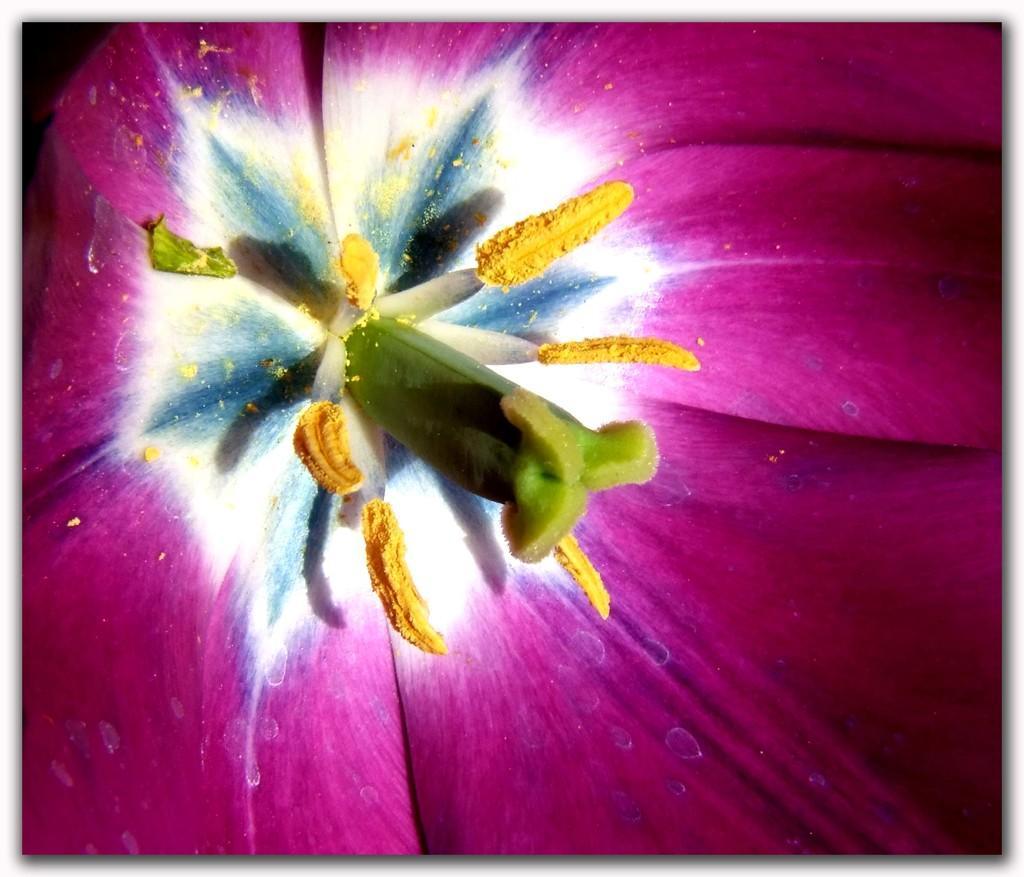In one or two sentences, can you explain what this image depicts? In this picture we can see a flower, there are pollen grains in the middle. 